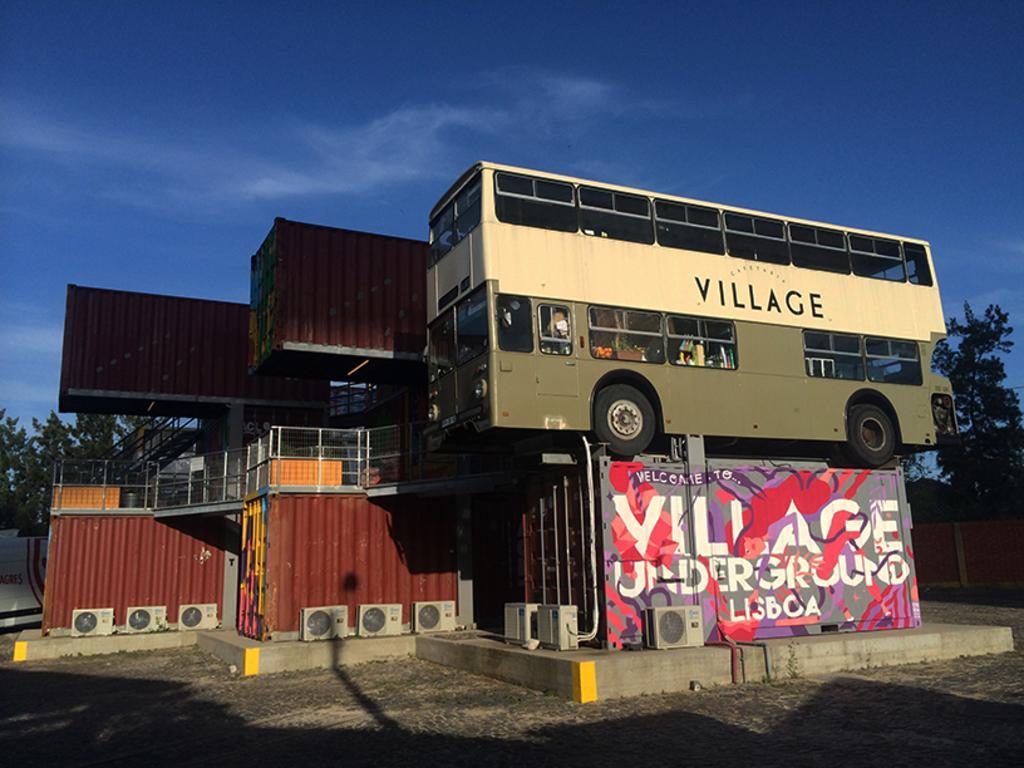Can you describe this image briefly? In this picture I can see a Double Decker bus, containers, air conditioners, fence, stairs, staircase holders and some other objects. I can see trees, and in the background there is the sky. 